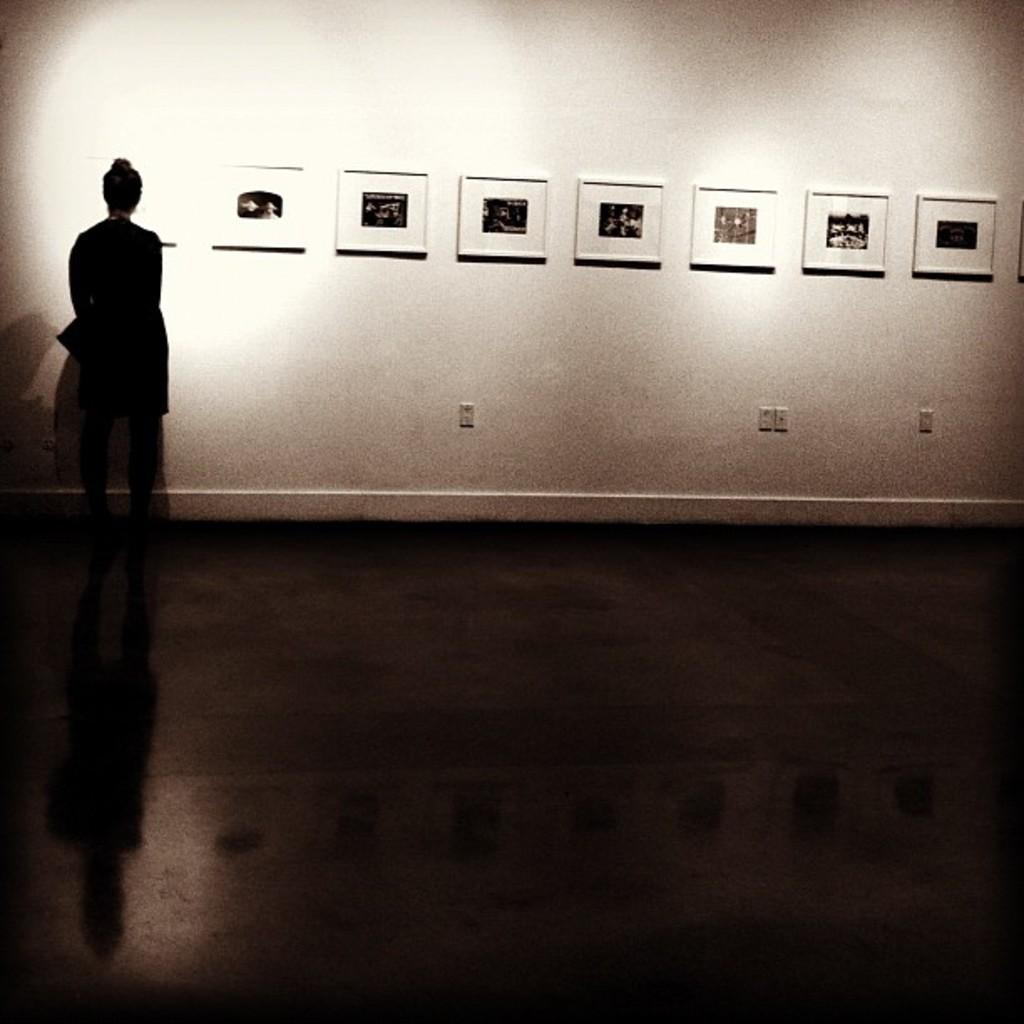What is the main subject in the image? There is a person in the image. What can be seen on the wall in the image? There are photo frames on the wall. Can you describe anything related to the person's shadow in the image? The shadow of a person is visible on the floor. Is there an airport visible in the image? No, there is no airport present in the image. Can you see an island in the background of the image? No, there is no island is visible in the image. 